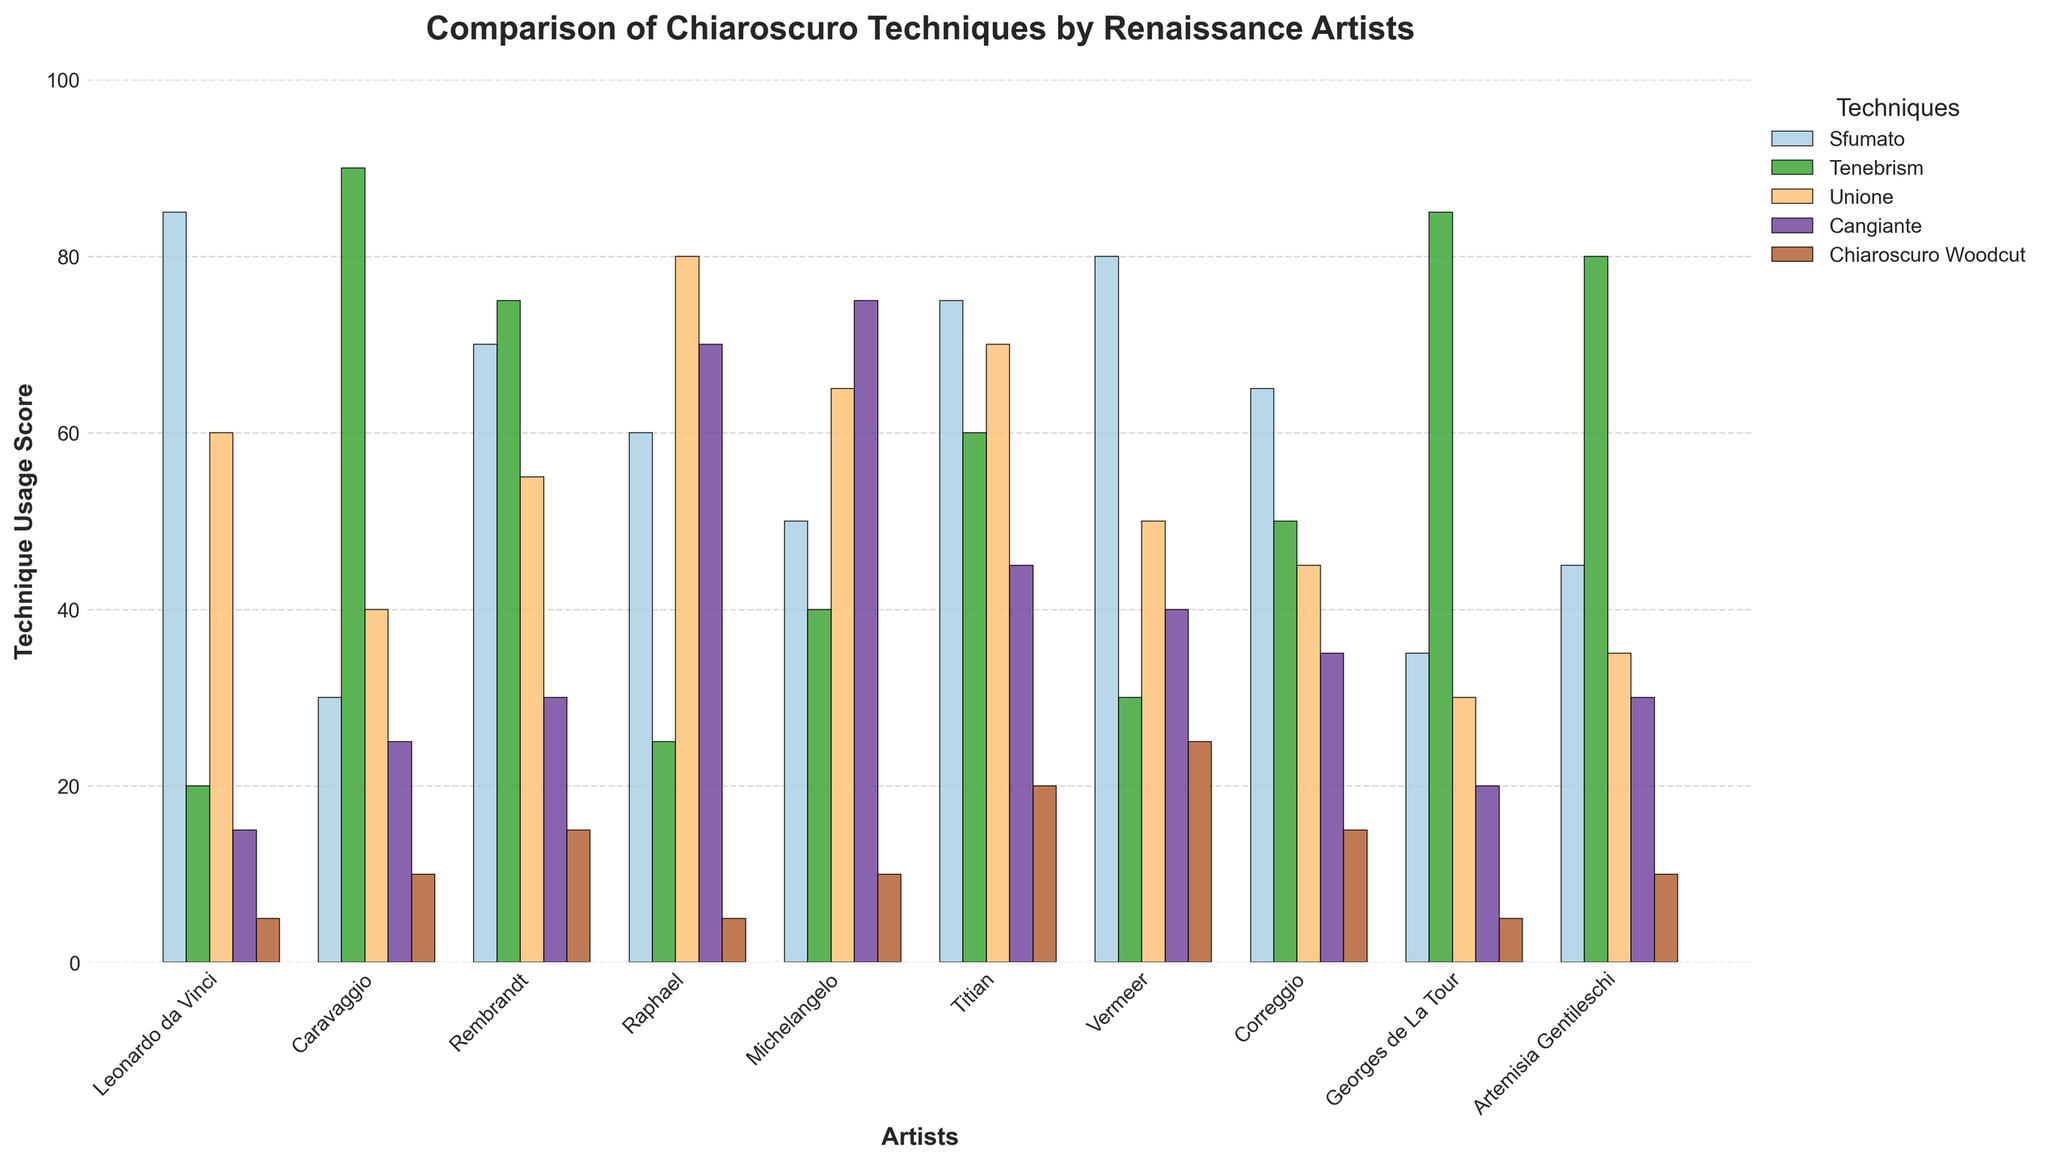Which artist employed the Sfumato technique the most? The 'Sfumato' bars across all artists show that Leonardo da Vinci has the tallest bar for this technique.
Answer: Leonardo da Vinci Which two artists have the highest usage scores for Tenebrism combined? Adding the 'Tenebrism' scores, Caravaggio has 90 and Georges de La Tour has 85, which sum up to 175, higher than any other combination.
Answer: Caravaggio and Georges de La Tour Which artist shows a more balanced usage across all techniques? Comparing the heights of the bars for each artist, Titian has relatively similar heights across all five techniques, suggesting a more balanced usage.
Answer: Titian Are there any techniques for which the usage scores of all artists are less than 100? By examining the y-axis and the tallest bars for each technique, all highest bars for each technique—Sfumato, Tenebrism, Unione, Cangiante, and Chiaroscuro Woodcut—are under 100.
Answer: Yes What is the difference in the usage score of Unione between Raphael and Correggio? Subtracting Correggio's 'Unione' score of 45 from Raphael's 'Unione' score of 80 gives a difference of 35.
Answer: 35 Which technique is represented with the color closest to blue in the chart? Identifying the colors used and matching them to their techniques, Tenebrism is represented with a color closest to blue.
Answer: Tenebrism Who ranked first and last in the usage of Chiaroscuro Woodcut? Observing the heights of the 'Chiaroscuro Woodcut' bars, Vermeer ranks first and Leonardo da Vinci and Georges de La Tour both rank last.
Answer: Vermeer first, Leonardo da Vinci and Georges de La Tour last What is the total usage score of the Cangiante technique by all artists? Summing the 'Cangiante' scores, 15 + 25 + 30 + 70 + 75 + 45 + 40 + 35 + 20 + 30 equals 385.
Answer: 385 Which artist's Sfumato usage is closest to the average Sfumato usage across all artists? Calculating the average of all 'Sfumato' values and comparing the differences, (85 + 30 + 70 + 60 + 50 + 75 + 80 + 65 + 35 + 45) / 10 = 59.5, Raphael's usage at 60 is closest to the average.
Answer: Raphael What is the combined total score for Leonardo da Vinci for all techniques? Summing all techniques for Leonardo da Vinci: 85 + 20 + 60 + 15 + 5 equals 185.
Answer: 185 